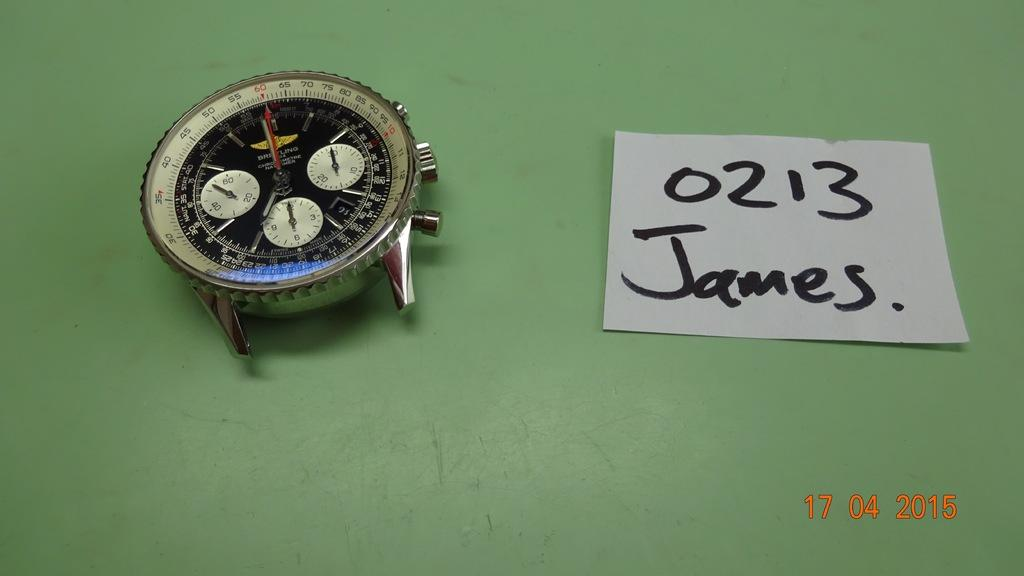<image>
Create a compact narrative representing the image presented. A watch face is set on a green background next to a piece of paper that 0213 James written on it. 